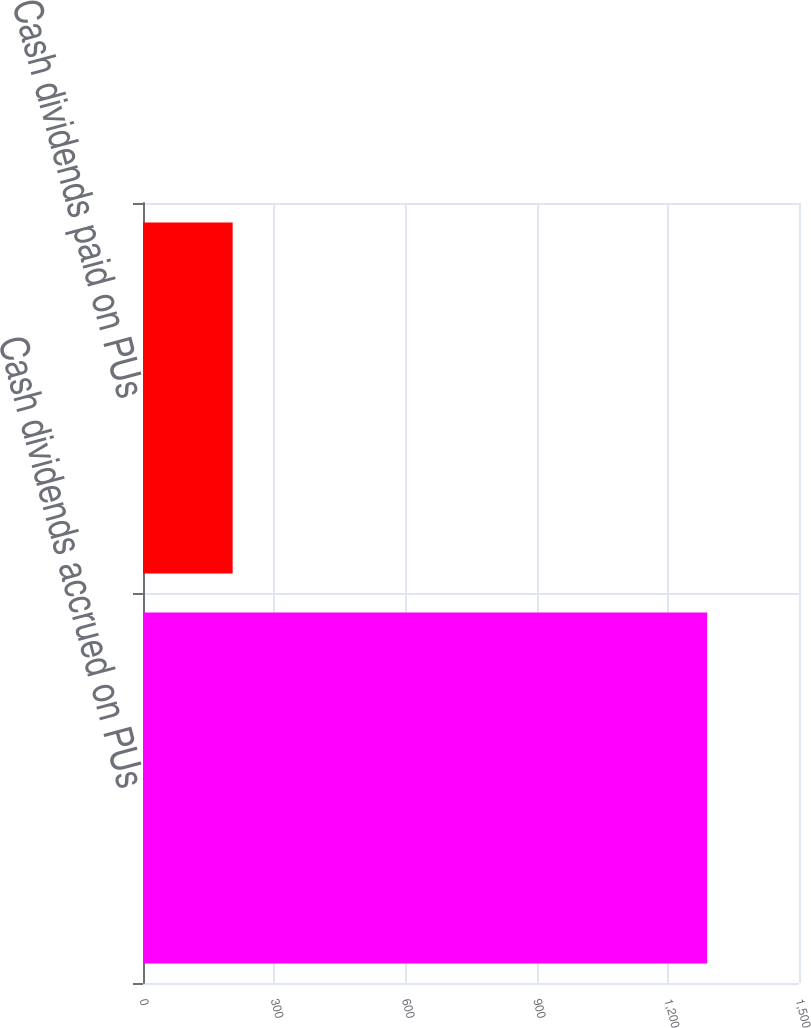Convert chart. <chart><loc_0><loc_0><loc_500><loc_500><bar_chart><fcel>Cash dividends accrued on PUs<fcel>Cash dividends paid on PUs<nl><fcel>1290<fcel>205<nl></chart> 